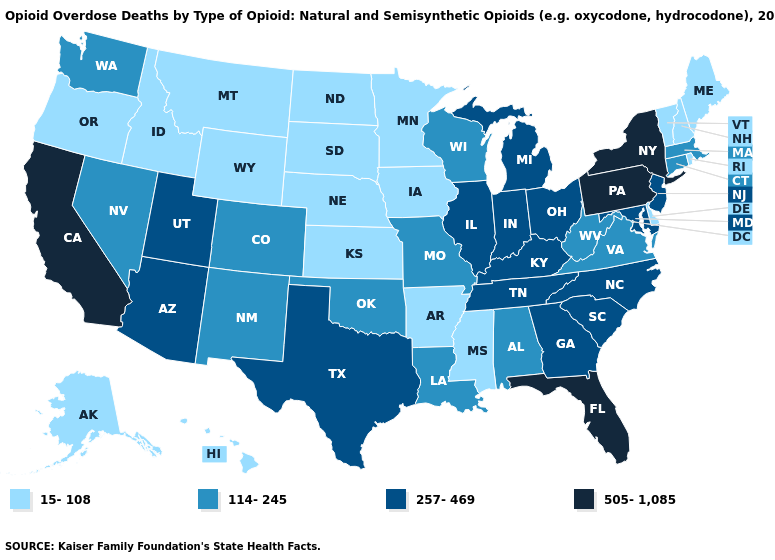What is the highest value in the USA?
Write a very short answer. 505-1,085. Among the states that border Kansas , which have the highest value?
Be succinct. Colorado, Missouri, Oklahoma. Name the states that have a value in the range 505-1,085?
Short answer required. California, Florida, New York, Pennsylvania. How many symbols are there in the legend?
Keep it brief. 4. Does the map have missing data?
Short answer required. No. What is the value of Nevada?
Keep it brief. 114-245. What is the lowest value in states that border Pennsylvania?
Give a very brief answer. 15-108. What is the lowest value in the USA?
Be succinct. 15-108. What is the value of Wyoming?
Quick response, please. 15-108. Does the map have missing data?
Give a very brief answer. No. What is the lowest value in states that border Kentucky?
Keep it brief. 114-245. Name the states that have a value in the range 15-108?
Keep it brief. Alaska, Arkansas, Delaware, Hawaii, Idaho, Iowa, Kansas, Maine, Minnesota, Mississippi, Montana, Nebraska, New Hampshire, North Dakota, Oregon, Rhode Island, South Dakota, Vermont, Wyoming. What is the lowest value in the USA?
Be succinct. 15-108. Does Pennsylvania have the highest value in the USA?
Concise answer only. Yes. Does Virginia have the highest value in the South?
Answer briefly. No. 